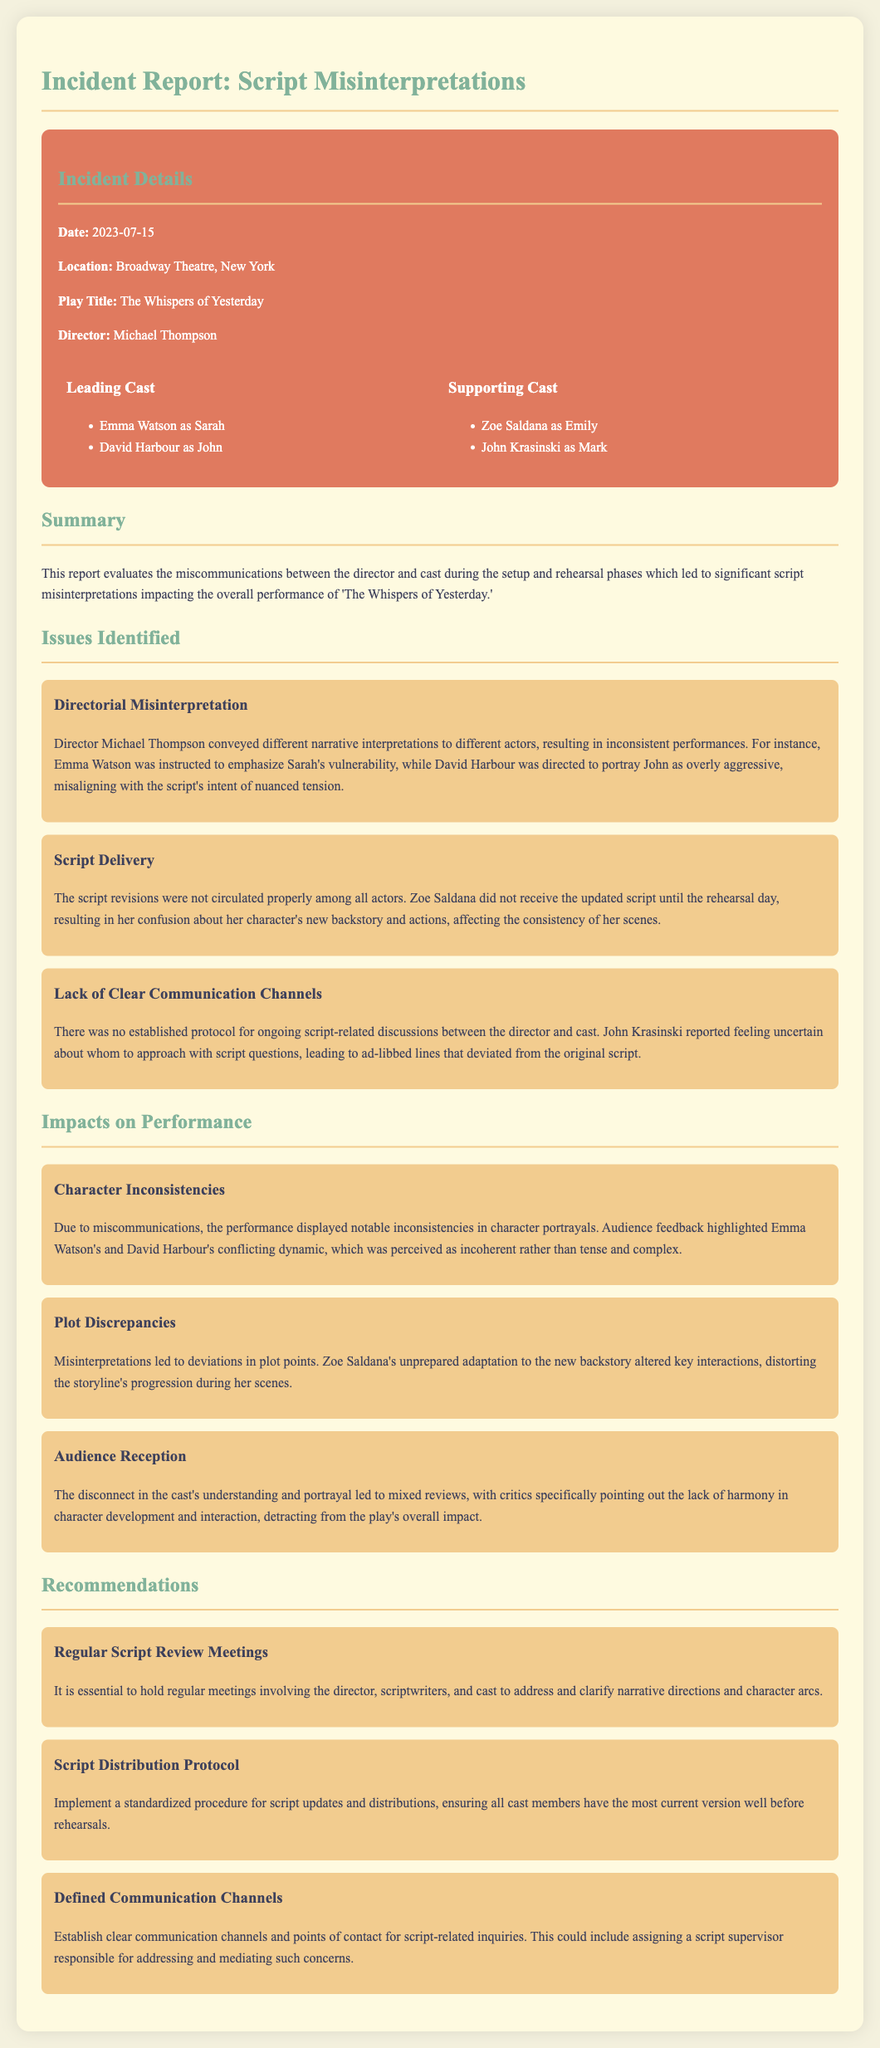What is the date of the incident? The date of the incident is clearly listed in the document section titled "Incident Details."
Answer: 2023-07-15 Who is the director of the play? The document mentions the director's name in the "Incident Details" section.
Answer: Michael Thompson What play is the report about? The title of the play is indicated in the "Incident Details" section in the document.
Answer: The Whispers of Yesterday What issue did John Krasinski report? The issue reported by John Krasinski is found in the "Lack of Clear Communication Channels" section of the "Issues Identified."
Answer: Uncertainty about whom to approach Which character's portrayal did audience feedback highlight as incoherent? Audience feedback highlighted character discrepancies in the "Character Inconsistencies" section of the "Impacts on Performance."
Answer: Emma Watson's and David Harbour's What is one recommendation for improving communication? The recommendations section suggests methods for enhancing communication, which can be found in the "Recommendations" heading.
Answer: Defined Communication Channels 